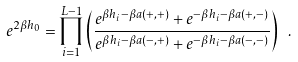Convert formula to latex. <formula><loc_0><loc_0><loc_500><loc_500>e ^ { 2 \beta h _ { 0 } } = \prod _ { i = 1 } ^ { L - 1 } \left ( \frac { e ^ { \beta h _ { i } - \beta a ( + , + ) } + e ^ { - \beta h _ { i } - \beta a ( + , - ) } } { e ^ { \beta h _ { i } - \beta a ( - , + ) } + e ^ { - \beta h _ { i } - \beta a ( - , - ) } } \right ) \ .</formula> 